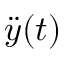<formula> <loc_0><loc_0><loc_500><loc_500>{ \ddot { y } } ( t )</formula> 